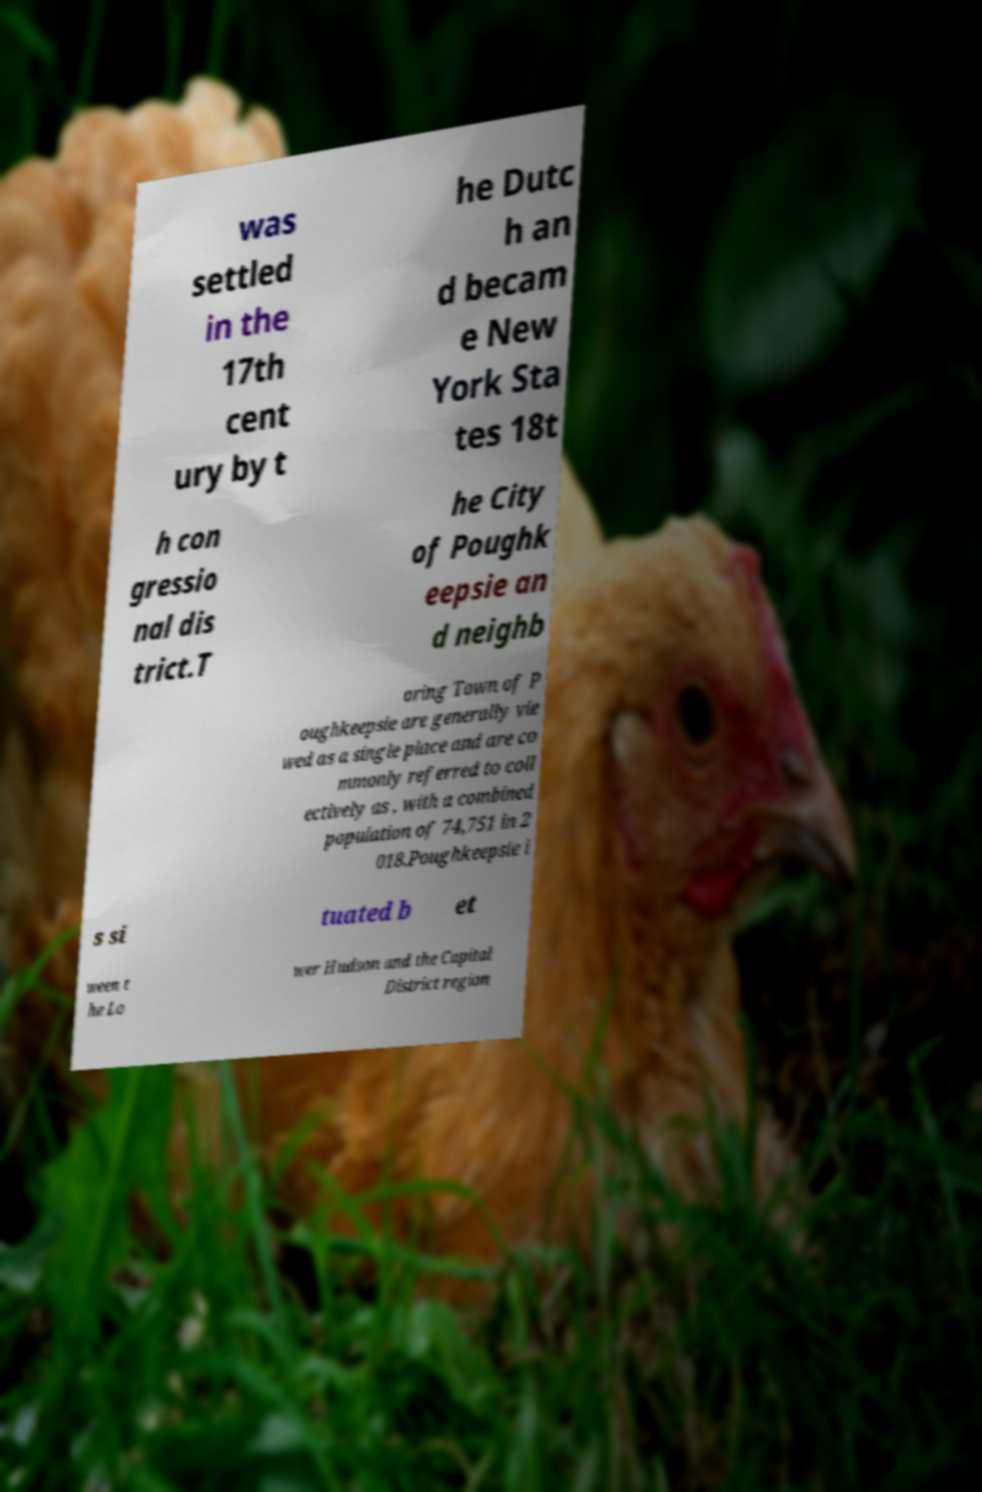Please read and relay the text visible in this image. What does it say? was settled in the 17th cent ury by t he Dutc h an d becam e New York Sta tes 18t h con gressio nal dis trict.T he City of Poughk eepsie an d neighb oring Town of P oughkeepsie are generally vie wed as a single place and are co mmonly referred to coll ectively as , with a combined population of 74,751 in 2 018.Poughkeepsie i s si tuated b et ween t he Lo wer Hudson and the Capital District region 